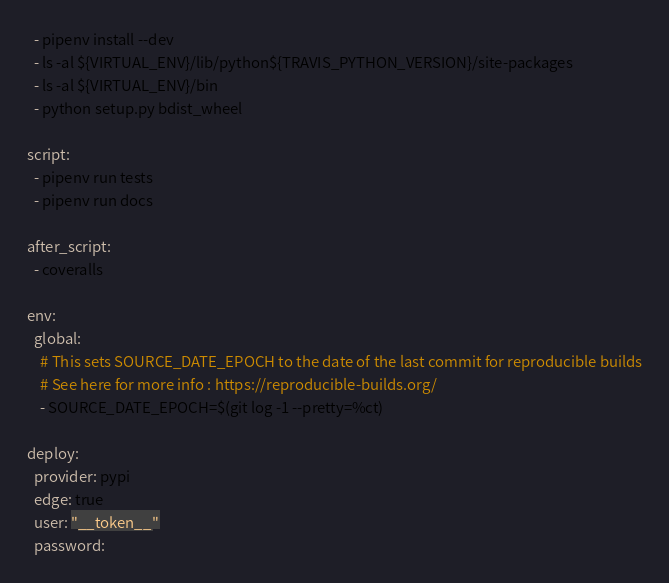Convert code to text. <code><loc_0><loc_0><loc_500><loc_500><_YAML_>  - pipenv install --dev
  - ls -al ${VIRTUAL_ENV}/lib/python${TRAVIS_PYTHON_VERSION}/site-packages
  - ls -al ${VIRTUAL_ENV}/bin
  - python setup.py bdist_wheel

script:
  - pipenv run tests
  - pipenv run docs

after_script:
  - coveralls

env:
  global:
    # This sets SOURCE_DATE_EPOCH to the date of the last commit for reproducible builds
    # See here for more info : https://reproducible-builds.org/
    - SOURCE_DATE_EPOCH=$(git log -1 --pretty=%ct)

deploy:
  provider: pypi
  edge: true
  user: "__token__"
  password:</code> 